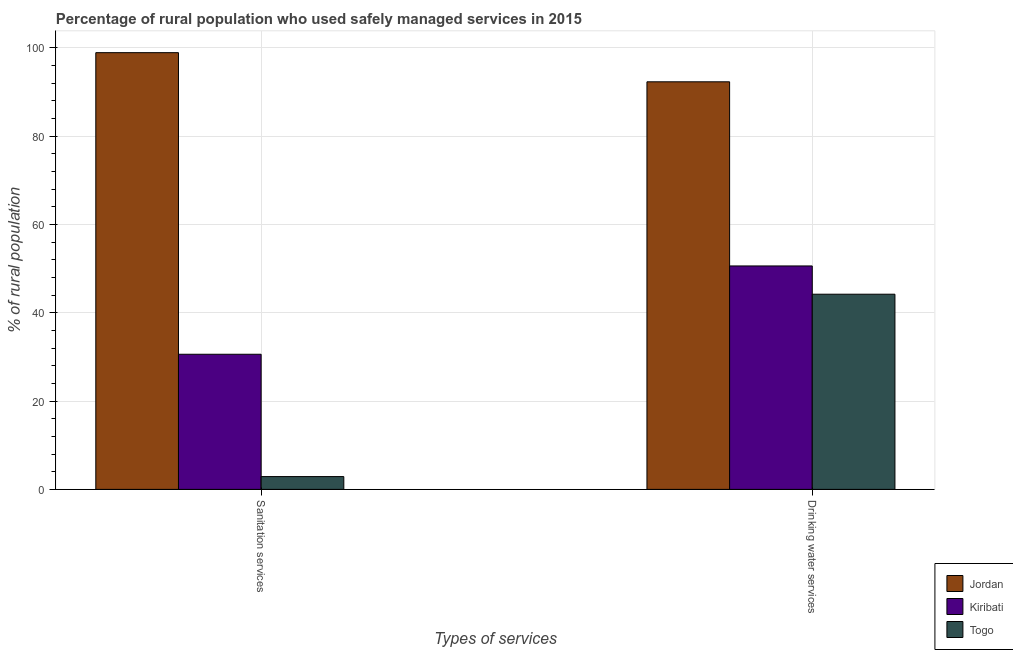How many different coloured bars are there?
Ensure brevity in your answer.  3. How many groups of bars are there?
Your response must be concise. 2. Are the number of bars on each tick of the X-axis equal?
Provide a short and direct response. Yes. How many bars are there on the 2nd tick from the left?
Provide a succinct answer. 3. How many bars are there on the 1st tick from the right?
Offer a terse response. 3. What is the label of the 2nd group of bars from the left?
Provide a short and direct response. Drinking water services. What is the percentage of rural population who used drinking water services in Togo?
Offer a terse response. 44.2. Across all countries, what is the maximum percentage of rural population who used sanitation services?
Provide a succinct answer. 98.9. Across all countries, what is the minimum percentage of rural population who used sanitation services?
Your answer should be compact. 2.9. In which country was the percentage of rural population who used drinking water services maximum?
Ensure brevity in your answer.  Jordan. In which country was the percentage of rural population who used sanitation services minimum?
Your response must be concise. Togo. What is the total percentage of rural population who used drinking water services in the graph?
Provide a short and direct response. 187.1. What is the difference between the percentage of rural population who used drinking water services in Kiribati and that in Jordan?
Provide a short and direct response. -41.7. What is the difference between the percentage of rural population who used drinking water services in Togo and the percentage of rural population who used sanitation services in Jordan?
Your answer should be compact. -54.7. What is the average percentage of rural population who used drinking water services per country?
Make the answer very short. 62.37. What is the difference between the percentage of rural population who used sanitation services and percentage of rural population who used drinking water services in Jordan?
Provide a succinct answer. 6.6. What is the ratio of the percentage of rural population who used drinking water services in Jordan to that in Togo?
Provide a short and direct response. 2.09. In how many countries, is the percentage of rural population who used sanitation services greater than the average percentage of rural population who used sanitation services taken over all countries?
Give a very brief answer. 1. What does the 3rd bar from the left in Sanitation services represents?
Offer a very short reply. Togo. What does the 2nd bar from the right in Sanitation services represents?
Offer a terse response. Kiribati. How many bars are there?
Your answer should be compact. 6. Are all the bars in the graph horizontal?
Your answer should be very brief. No. Are the values on the major ticks of Y-axis written in scientific E-notation?
Give a very brief answer. No. Does the graph contain any zero values?
Offer a very short reply. No. Where does the legend appear in the graph?
Your response must be concise. Bottom right. How many legend labels are there?
Offer a terse response. 3. How are the legend labels stacked?
Offer a very short reply. Vertical. What is the title of the graph?
Your answer should be compact. Percentage of rural population who used safely managed services in 2015. Does "Maldives" appear as one of the legend labels in the graph?
Your answer should be very brief. No. What is the label or title of the X-axis?
Your answer should be compact. Types of services. What is the label or title of the Y-axis?
Offer a very short reply. % of rural population. What is the % of rural population in Jordan in Sanitation services?
Keep it short and to the point. 98.9. What is the % of rural population in Kiribati in Sanitation services?
Your answer should be compact. 30.6. What is the % of rural population in Jordan in Drinking water services?
Your answer should be very brief. 92.3. What is the % of rural population in Kiribati in Drinking water services?
Your answer should be compact. 50.6. What is the % of rural population in Togo in Drinking water services?
Your answer should be compact. 44.2. Across all Types of services, what is the maximum % of rural population in Jordan?
Provide a succinct answer. 98.9. Across all Types of services, what is the maximum % of rural population of Kiribati?
Offer a terse response. 50.6. Across all Types of services, what is the maximum % of rural population of Togo?
Make the answer very short. 44.2. Across all Types of services, what is the minimum % of rural population of Jordan?
Offer a very short reply. 92.3. Across all Types of services, what is the minimum % of rural population of Kiribati?
Your answer should be compact. 30.6. Across all Types of services, what is the minimum % of rural population of Togo?
Make the answer very short. 2.9. What is the total % of rural population of Jordan in the graph?
Make the answer very short. 191.2. What is the total % of rural population of Kiribati in the graph?
Ensure brevity in your answer.  81.2. What is the total % of rural population in Togo in the graph?
Make the answer very short. 47.1. What is the difference between the % of rural population of Kiribati in Sanitation services and that in Drinking water services?
Your answer should be very brief. -20. What is the difference between the % of rural population of Togo in Sanitation services and that in Drinking water services?
Your answer should be very brief. -41.3. What is the difference between the % of rural population in Jordan in Sanitation services and the % of rural population in Kiribati in Drinking water services?
Give a very brief answer. 48.3. What is the difference between the % of rural population in Jordan in Sanitation services and the % of rural population in Togo in Drinking water services?
Provide a short and direct response. 54.7. What is the average % of rural population in Jordan per Types of services?
Keep it short and to the point. 95.6. What is the average % of rural population in Kiribati per Types of services?
Your answer should be compact. 40.6. What is the average % of rural population in Togo per Types of services?
Make the answer very short. 23.55. What is the difference between the % of rural population of Jordan and % of rural population of Kiribati in Sanitation services?
Your answer should be very brief. 68.3. What is the difference between the % of rural population in Jordan and % of rural population in Togo in Sanitation services?
Make the answer very short. 96. What is the difference between the % of rural population in Kiribati and % of rural population in Togo in Sanitation services?
Your response must be concise. 27.7. What is the difference between the % of rural population of Jordan and % of rural population of Kiribati in Drinking water services?
Offer a very short reply. 41.7. What is the difference between the % of rural population in Jordan and % of rural population in Togo in Drinking water services?
Offer a terse response. 48.1. What is the difference between the % of rural population in Kiribati and % of rural population in Togo in Drinking water services?
Provide a short and direct response. 6.4. What is the ratio of the % of rural population in Jordan in Sanitation services to that in Drinking water services?
Ensure brevity in your answer.  1.07. What is the ratio of the % of rural population in Kiribati in Sanitation services to that in Drinking water services?
Provide a succinct answer. 0.6. What is the ratio of the % of rural population of Togo in Sanitation services to that in Drinking water services?
Ensure brevity in your answer.  0.07. What is the difference between the highest and the second highest % of rural population in Jordan?
Your answer should be compact. 6.6. What is the difference between the highest and the second highest % of rural population in Togo?
Your response must be concise. 41.3. What is the difference between the highest and the lowest % of rural population of Kiribati?
Offer a very short reply. 20. What is the difference between the highest and the lowest % of rural population in Togo?
Your answer should be very brief. 41.3. 